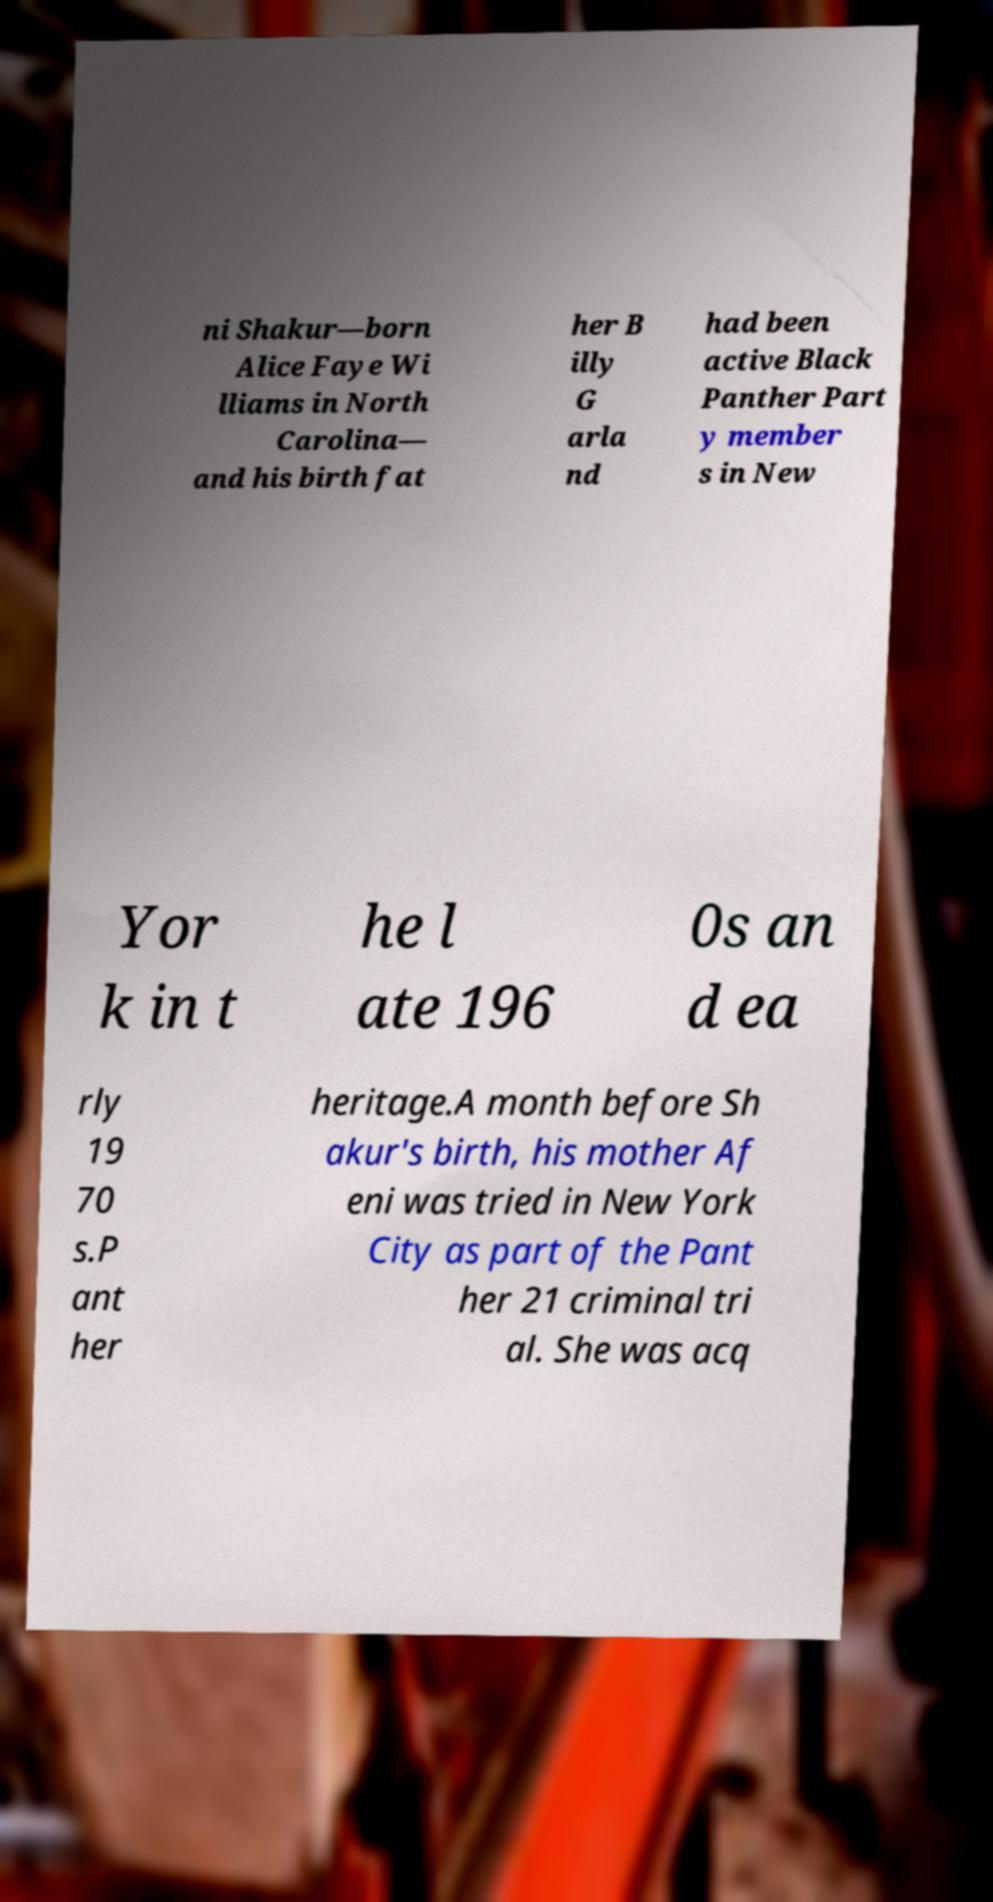For documentation purposes, I need the text within this image transcribed. Could you provide that? ni Shakur—born Alice Faye Wi lliams in North Carolina— and his birth fat her B illy G arla nd had been active Black Panther Part y member s in New Yor k in t he l ate 196 0s an d ea rly 19 70 s.P ant her heritage.A month before Sh akur's birth, his mother Af eni was tried in New York City as part of the Pant her 21 criminal tri al. She was acq 